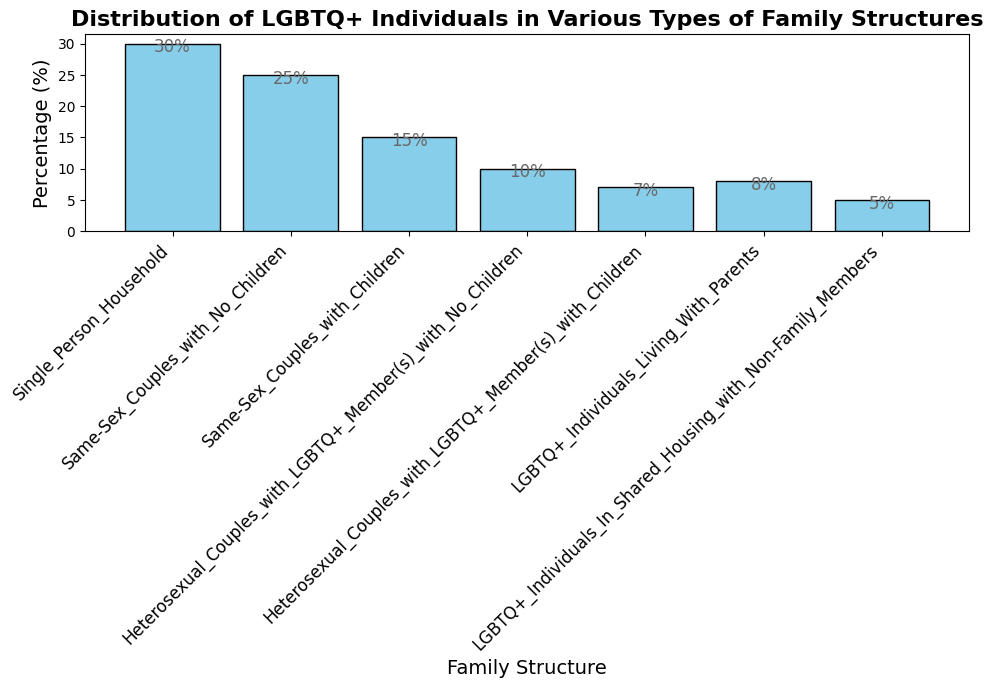What family structure has the highest percentage of LGBTQ+ individuals? By examining the lengths of the bars in the bar chart, the tallest bar represents "Single Person Household," which has the highest percentage at 30%.
Answer: Single Person Household Compare the percentage of LGBTQ+ individuals living in shared housing with non-family members to those living with parents. Which group is larger, and by how much? The bar representing "LGBTQ+ Individuals In Shared Housing with Non-Family Members" has a height corresponding to 5%, and the bar for "LGBTQ+ Individuals Living With Parents" corresponds to 8%. The group living with parents is larger by 3%.
Answer: LGBTQ+ Individuals Living With Parents, 3% What is the total percentage of LGBTQ+ individuals in heterosexual family structures? Sum the percentages of "Heterosexual Couples with LGBTQ+ Member(s) with No Children" (10%) and "Heterosexual Couples with LGBTQ+ Member(s) with Children" (7%) which is 10% + 7% = 17%.
Answer: 17% What is the difference in percentage between "Single Person Household" and "Same-Sex Couples with No Children"? The percentage for "Single Person Household" is 30% and for "Same-Sex Couples with No Children" is 25%. The difference is 30% - 25% = 5%.
Answer: 5% What percentage of LGBTQ+ individuals are in family structures that include children (both same-sex and heterosexual)? Add the percentages for "Same-Sex Couples with Children" (15%) and "Heterosexual Couples with LGBTQ+ Member(s) with Children" (7%), which gives 15% + 7% = 22%.
Answer: 22% Which family structure has the lowest representation of LGBTQ+ individuals, and what is its percentage? By looking at the heights of the bars, the shortest bar represents "LGBTQ+ Individuals In Shared Housing with Non-Family Members," with a percentage of 5%.
Answer: LGBTQ+ Individuals In Shared Housing with Non-Family Members, 5% Compare the combined percentage of LGBTQ+ individuals in "Single Person Household" and "Same-Sex Couples with No Children" to the combined percentage of all other family structures. Which combined percentage is higher? Sum the percentages of "Single Person Household" (30%) and "Same-Sex Couples with No Children" (25%), which gives 30% + 25% = 55%. Sum the percentages of all other structures: 15% (Same-Sex Couples with Children) + 10% (Heterosexual Couples with LGBTQ+ Member(s) with No Children) + 7% (Heterosexual Couples with LGBTQ+ Member(s) with Children) + 8% (LGBTQ+ Individuals Living With Parents) + 5% (LGBTQ+ Individuals In Shared Housing with Non-Family Members) = 45%. The combined percentage of "Single Person Household" and "Same-Sex Couples with No Children" is higher (55% vs. 45%).
Answer: Single Person Household and Same-Sex Couples with No Children, 55% 